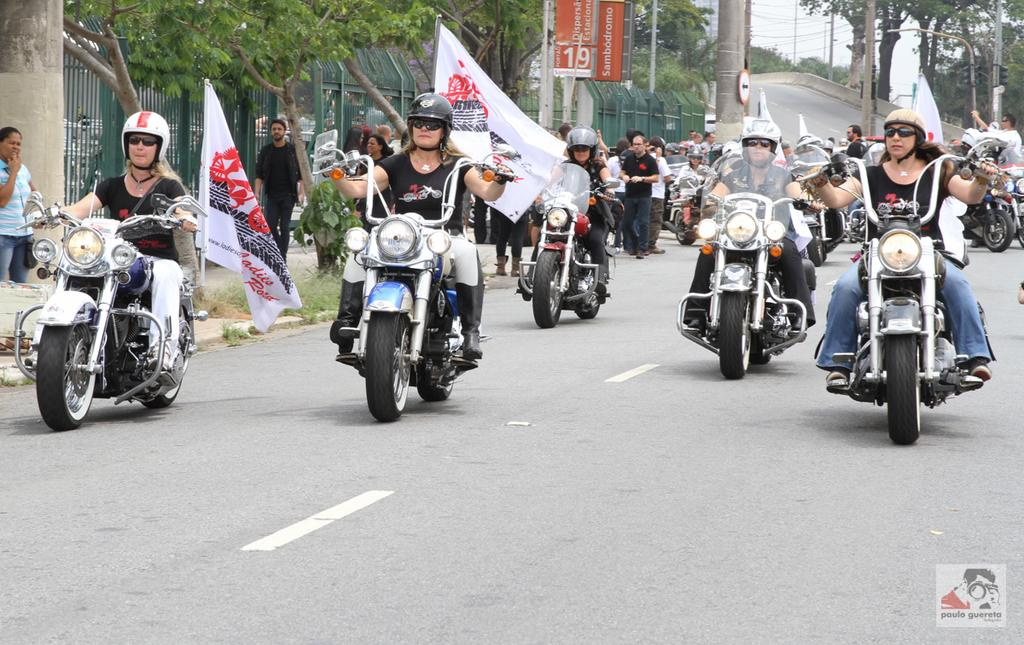What is the main subject of the image? The main subject of the image is a group of women. What are the women doing in the image? The women are riding bikes. Can you describe the background of the image? There are trees in the background of the image. What type of range can be seen in the image? There is no range present in the image. Are there any fish visible in the image? There are no fish present in the image. 